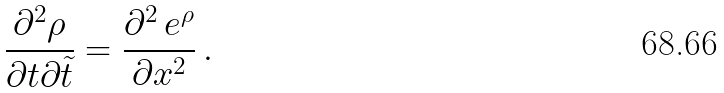<formula> <loc_0><loc_0><loc_500><loc_500>\frac { \partial ^ { 2 } \rho } { \partial t \partial { \tilde { t } } } = \frac { \partial ^ { 2 } \, e ^ { \rho } } { \partial x ^ { 2 } } \, .</formula> 